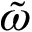<formula> <loc_0><loc_0><loc_500><loc_500>\tilde { \omega }</formula> 